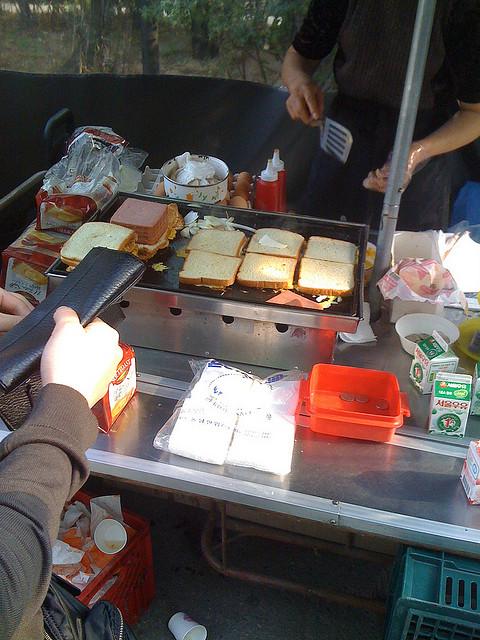How many sandwiches are on the grill?
Keep it brief. 6. Is this man selling food?
Quick response, please. Yes. What color is the object is being used for trash?
Keep it brief. Red. 